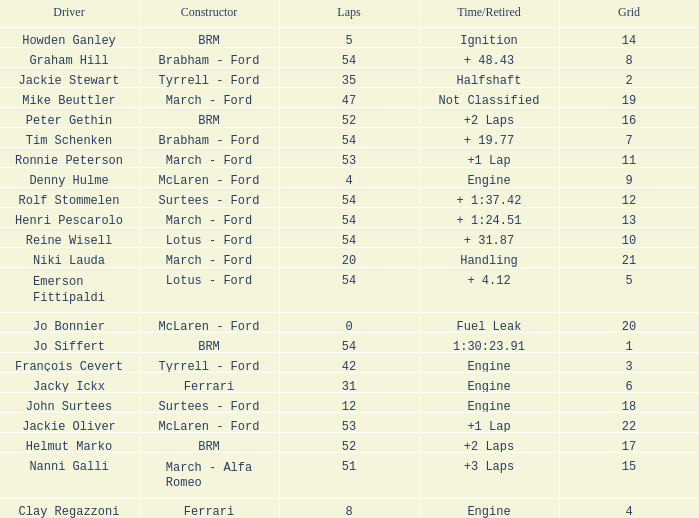What is the low grid that has brm and over 54 laps? None. 